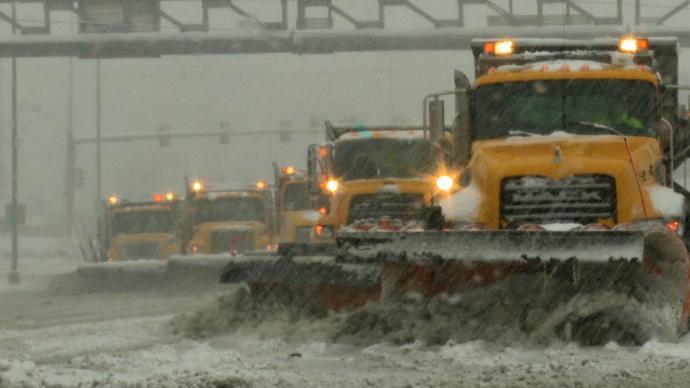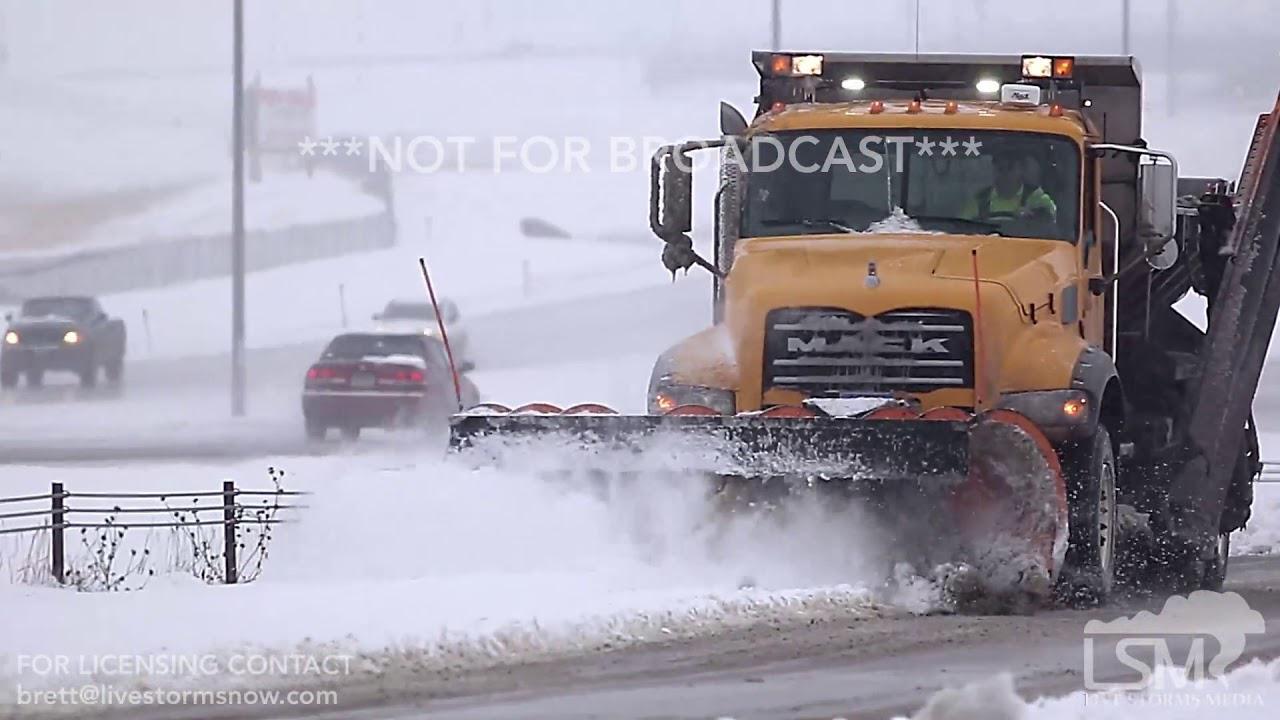The first image is the image on the left, the second image is the image on the right. Considering the images on both sides, is "There is a line of plows in the right image and a single plow in the left." valid? Answer yes or no. No. The first image is the image on the left, the second image is the image on the right. For the images shown, is this caption "Both images show the front side of a snow plow." true? Answer yes or no. Yes. 